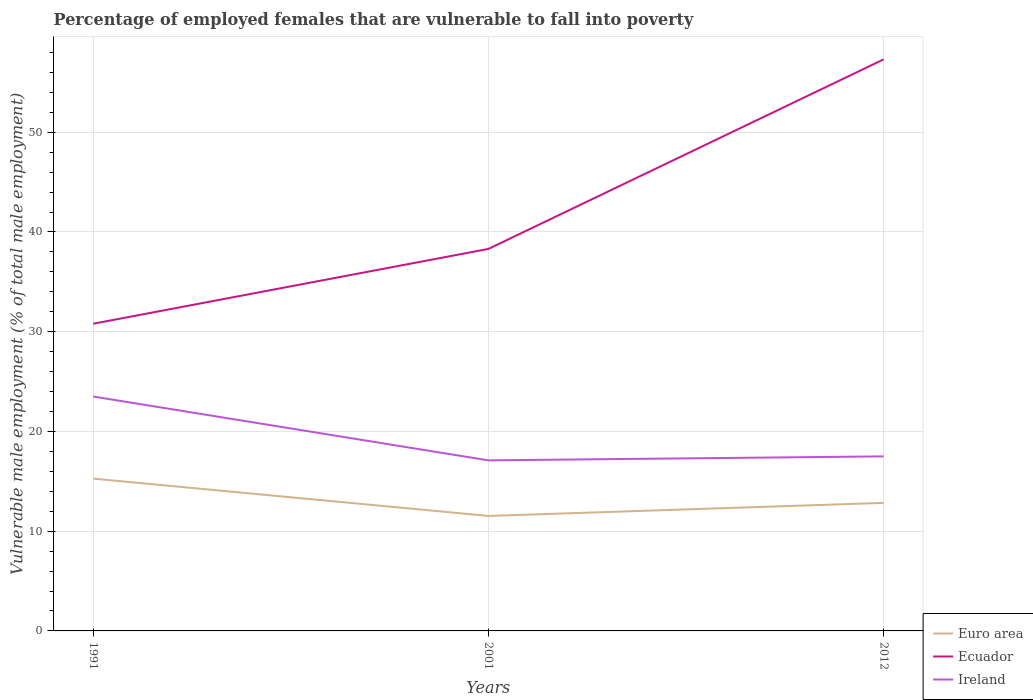Is the number of lines equal to the number of legend labels?
Ensure brevity in your answer.  Yes. Across all years, what is the maximum percentage of employed females who are vulnerable to fall into poverty in Ecuador?
Your answer should be compact. 30.8. What is the total percentage of employed females who are vulnerable to fall into poverty in Euro area in the graph?
Your answer should be compact. -1.31. What is the difference between the highest and the second highest percentage of employed females who are vulnerable to fall into poverty in Euro area?
Your response must be concise. 3.74. What is the difference between the highest and the lowest percentage of employed females who are vulnerable to fall into poverty in Euro area?
Offer a very short reply. 1. What is the difference between two consecutive major ticks on the Y-axis?
Your answer should be compact. 10. What is the title of the graph?
Provide a short and direct response. Percentage of employed females that are vulnerable to fall into poverty. What is the label or title of the Y-axis?
Your answer should be compact. Vulnerable male employment (% of total male employment). What is the Vulnerable male employment (% of total male employment) of Euro area in 1991?
Ensure brevity in your answer.  15.27. What is the Vulnerable male employment (% of total male employment) in Ecuador in 1991?
Your answer should be compact. 30.8. What is the Vulnerable male employment (% of total male employment) in Ireland in 1991?
Your response must be concise. 23.5. What is the Vulnerable male employment (% of total male employment) of Euro area in 2001?
Provide a succinct answer. 11.53. What is the Vulnerable male employment (% of total male employment) in Ecuador in 2001?
Ensure brevity in your answer.  38.3. What is the Vulnerable male employment (% of total male employment) of Ireland in 2001?
Keep it short and to the point. 17.1. What is the Vulnerable male employment (% of total male employment) of Euro area in 2012?
Your answer should be very brief. 12.84. What is the Vulnerable male employment (% of total male employment) of Ecuador in 2012?
Ensure brevity in your answer.  57.3. What is the Vulnerable male employment (% of total male employment) in Ireland in 2012?
Your response must be concise. 17.5. Across all years, what is the maximum Vulnerable male employment (% of total male employment) of Euro area?
Your answer should be compact. 15.27. Across all years, what is the maximum Vulnerable male employment (% of total male employment) in Ecuador?
Your answer should be very brief. 57.3. Across all years, what is the maximum Vulnerable male employment (% of total male employment) of Ireland?
Your response must be concise. 23.5. Across all years, what is the minimum Vulnerable male employment (% of total male employment) of Euro area?
Provide a short and direct response. 11.53. Across all years, what is the minimum Vulnerable male employment (% of total male employment) of Ecuador?
Give a very brief answer. 30.8. Across all years, what is the minimum Vulnerable male employment (% of total male employment) of Ireland?
Provide a succinct answer. 17.1. What is the total Vulnerable male employment (% of total male employment) of Euro area in the graph?
Ensure brevity in your answer.  39.63. What is the total Vulnerable male employment (% of total male employment) in Ecuador in the graph?
Keep it short and to the point. 126.4. What is the total Vulnerable male employment (% of total male employment) of Ireland in the graph?
Make the answer very short. 58.1. What is the difference between the Vulnerable male employment (% of total male employment) in Euro area in 1991 and that in 2001?
Your answer should be very brief. 3.74. What is the difference between the Vulnerable male employment (% of total male employment) of Euro area in 1991 and that in 2012?
Keep it short and to the point. 2.43. What is the difference between the Vulnerable male employment (% of total male employment) in Ecuador in 1991 and that in 2012?
Your answer should be very brief. -26.5. What is the difference between the Vulnerable male employment (% of total male employment) of Ireland in 1991 and that in 2012?
Give a very brief answer. 6. What is the difference between the Vulnerable male employment (% of total male employment) of Euro area in 2001 and that in 2012?
Your answer should be very brief. -1.31. What is the difference between the Vulnerable male employment (% of total male employment) of Ecuador in 2001 and that in 2012?
Ensure brevity in your answer.  -19. What is the difference between the Vulnerable male employment (% of total male employment) in Ireland in 2001 and that in 2012?
Your response must be concise. -0.4. What is the difference between the Vulnerable male employment (% of total male employment) of Euro area in 1991 and the Vulnerable male employment (% of total male employment) of Ecuador in 2001?
Your answer should be very brief. -23.03. What is the difference between the Vulnerable male employment (% of total male employment) of Euro area in 1991 and the Vulnerable male employment (% of total male employment) of Ireland in 2001?
Provide a short and direct response. -1.83. What is the difference between the Vulnerable male employment (% of total male employment) in Euro area in 1991 and the Vulnerable male employment (% of total male employment) in Ecuador in 2012?
Offer a terse response. -42.03. What is the difference between the Vulnerable male employment (% of total male employment) of Euro area in 1991 and the Vulnerable male employment (% of total male employment) of Ireland in 2012?
Give a very brief answer. -2.23. What is the difference between the Vulnerable male employment (% of total male employment) in Ecuador in 1991 and the Vulnerable male employment (% of total male employment) in Ireland in 2012?
Keep it short and to the point. 13.3. What is the difference between the Vulnerable male employment (% of total male employment) of Euro area in 2001 and the Vulnerable male employment (% of total male employment) of Ecuador in 2012?
Give a very brief answer. -45.77. What is the difference between the Vulnerable male employment (% of total male employment) in Euro area in 2001 and the Vulnerable male employment (% of total male employment) in Ireland in 2012?
Provide a short and direct response. -5.97. What is the difference between the Vulnerable male employment (% of total male employment) of Ecuador in 2001 and the Vulnerable male employment (% of total male employment) of Ireland in 2012?
Provide a short and direct response. 20.8. What is the average Vulnerable male employment (% of total male employment) of Euro area per year?
Provide a succinct answer. 13.21. What is the average Vulnerable male employment (% of total male employment) in Ecuador per year?
Give a very brief answer. 42.13. What is the average Vulnerable male employment (% of total male employment) in Ireland per year?
Give a very brief answer. 19.37. In the year 1991, what is the difference between the Vulnerable male employment (% of total male employment) of Euro area and Vulnerable male employment (% of total male employment) of Ecuador?
Ensure brevity in your answer.  -15.53. In the year 1991, what is the difference between the Vulnerable male employment (% of total male employment) of Euro area and Vulnerable male employment (% of total male employment) of Ireland?
Offer a terse response. -8.23. In the year 2001, what is the difference between the Vulnerable male employment (% of total male employment) in Euro area and Vulnerable male employment (% of total male employment) in Ecuador?
Your response must be concise. -26.77. In the year 2001, what is the difference between the Vulnerable male employment (% of total male employment) in Euro area and Vulnerable male employment (% of total male employment) in Ireland?
Your answer should be very brief. -5.57. In the year 2001, what is the difference between the Vulnerable male employment (% of total male employment) in Ecuador and Vulnerable male employment (% of total male employment) in Ireland?
Give a very brief answer. 21.2. In the year 2012, what is the difference between the Vulnerable male employment (% of total male employment) of Euro area and Vulnerable male employment (% of total male employment) of Ecuador?
Offer a terse response. -44.46. In the year 2012, what is the difference between the Vulnerable male employment (% of total male employment) in Euro area and Vulnerable male employment (% of total male employment) in Ireland?
Keep it short and to the point. -4.66. In the year 2012, what is the difference between the Vulnerable male employment (% of total male employment) in Ecuador and Vulnerable male employment (% of total male employment) in Ireland?
Your answer should be very brief. 39.8. What is the ratio of the Vulnerable male employment (% of total male employment) of Euro area in 1991 to that in 2001?
Offer a terse response. 1.32. What is the ratio of the Vulnerable male employment (% of total male employment) of Ecuador in 1991 to that in 2001?
Give a very brief answer. 0.8. What is the ratio of the Vulnerable male employment (% of total male employment) of Ireland in 1991 to that in 2001?
Give a very brief answer. 1.37. What is the ratio of the Vulnerable male employment (% of total male employment) of Euro area in 1991 to that in 2012?
Give a very brief answer. 1.19. What is the ratio of the Vulnerable male employment (% of total male employment) of Ecuador in 1991 to that in 2012?
Provide a succinct answer. 0.54. What is the ratio of the Vulnerable male employment (% of total male employment) in Ireland in 1991 to that in 2012?
Your answer should be very brief. 1.34. What is the ratio of the Vulnerable male employment (% of total male employment) in Euro area in 2001 to that in 2012?
Your answer should be compact. 0.9. What is the ratio of the Vulnerable male employment (% of total male employment) in Ecuador in 2001 to that in 2012?
Ensure brevity in your answer.  0.67. What is the ratio of the Vulnerable male employment (% of total male employment) of Ireland in 2001 to that in 2012?
Your response must be concise. 0.98. What is the difference between the highest and the second highest Vulnerable male employment (% of total male employment) of Euro area?
Make the answer very short. 2.43. What is the difference between the highest and the second highest Vulnerable male employment (% of total male employment) of Ecuador?
Give a very brief answer. 19. What is the difference between the highest and the lowest Vulnerable male employment (% of total male employment) of Euro area?
Your response must be concise. 3.74. What is the difference between the highest and the lowest Vulnerable male employment (% of total male employment) of Ireland?
Keep it short and to the point. 6.4. 